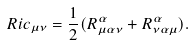Convert formula to latex. <formula><loc_0><loc_0><loc_500><loc_500>R i c _ { \mu \nu } = \frac { 1 } { 2 } ( R ^ { \alpha } _ { \mu \alpha \nu } + R ^ { \alpha } _ { \nu \alpha \mu } ) .</formula> 